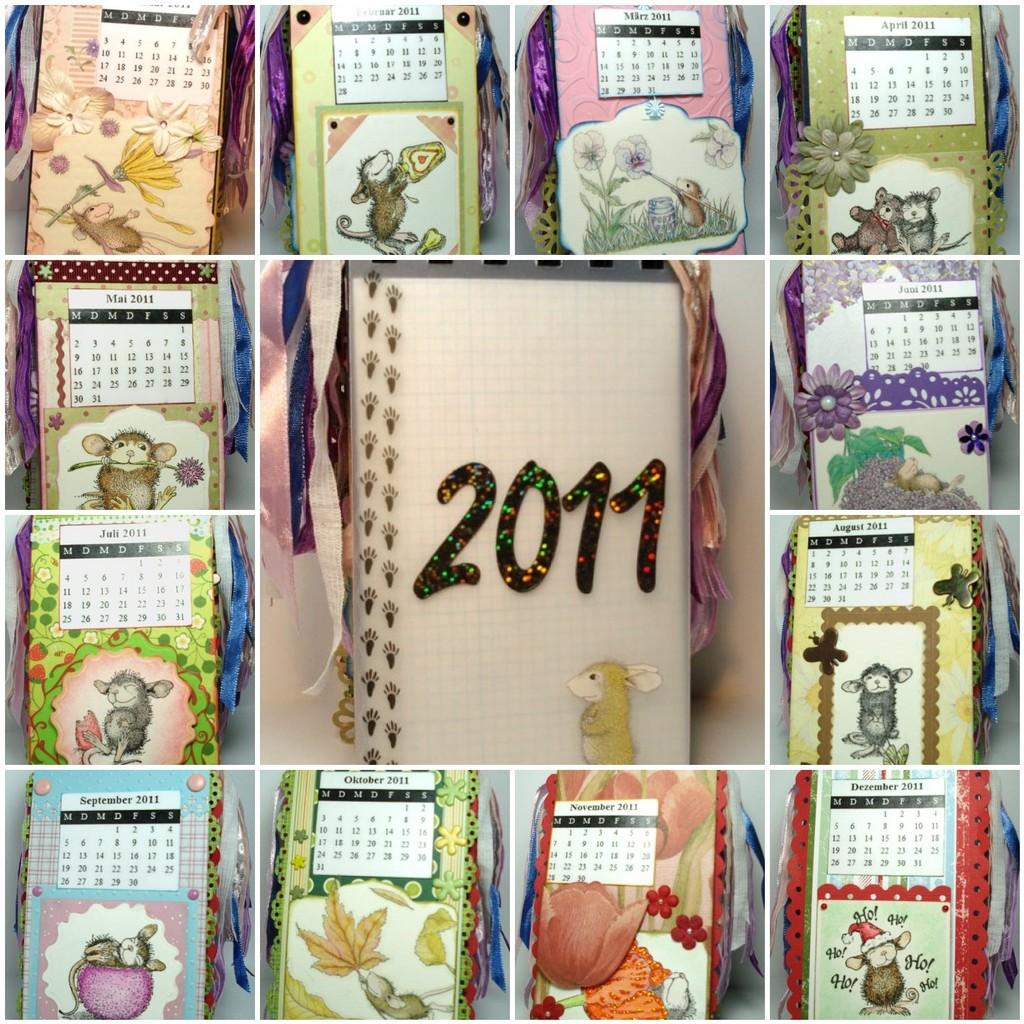What type of image is being described? The image is a collage of a calendar. Can you describe any specific details about the calendar? Unfortunately, the provided facts do not include any specific details about the calendar. How many rabbits are present in the image? There are no rabbits present in the image, as it is a collage of a calendar. What type of pest can be seen in the image? There is no pest present in the image, as it is a collage of a calendar. 